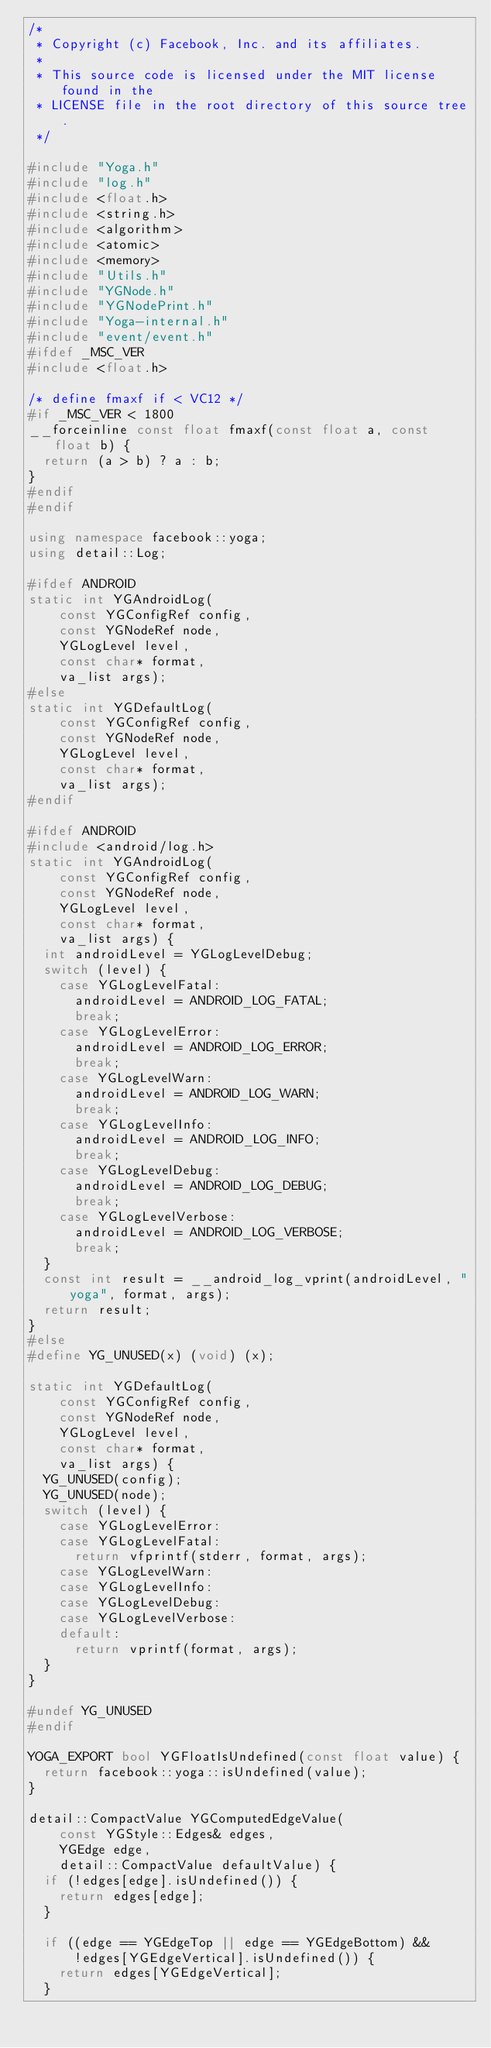<code> <loc_0><loc_0><loc_500><loc_500><_C++_>/*
 * Copyright (c) Facebook, Inc. and its affiliates.
 *
 * This source code is licensed under the MIT license found in the
 * LICENSE file in the root directory of this source tree.
 */

#include "Yoga.h"
#include "log.h"
#include <float.h>
#include <string.h>
#include <algorithm>
#include <atomic>
#include <memory>
#include "Utils.h"
#include "YGNode.h"
#include "YGNodePrint.h"
#include "Yoga-internal.h"
#include "event/event.h"
#ifdef _MSC_VER
#include <float.h>

/* define fmaxf if < VC12 */
#if _MSC_VER < 1800
__forceinline const float fmaxf(const float a, const float b) {
  return (a > b) ? a : b;
}
#endif
#endif

using namespace facebook::yoga;
using detail::Log;

#ifdef ANDROID
static int YGAndroidLog(
    const YGConfigRef config,
    const YGNodeRef node,
    YGLogLevel level,
    const char* format,
    va_list args);
#else
static int YGDefaultLog(
    const YGConfigRef config,
    const YGNodeRef node,
    YGLogLevel level,
    const char* format,
    va_list args);
#endif

#ifdef ANDROID
#include <android/log.h>
static int YGAndroidLog(
    const YGConfigRef config,
    const YGNodeRef node,
    YGLogLevel level,
    const char* format,
    va_list args) {
  int androidLevel = YGLogLevelDebug;
  switch (level) {
    case YGLogLevelFatal:
      androidLevel = ANDROID_LOG_FATAL;
      break;
    case YGLogLevelError:
      androidLevel = ANDROID_LOG_ERROR;
      break;
    case YGLogLevelWarn:
      androidLevel = ANDROID_LOG_WARN;
      break;
    case YGLogLevelInfo:
      androidLevel = ANDROID_LOG_INFO;
      break;
    case YGLogLevelDebug:
      androidLevel = ANDROID_LOG_DEBUG;
      break;
    case YGLogLevelVerbose:
      androidLevel = ANDROID_LOG_VERBOSE;
      break;
  }
  const int result = __android_log_vprint(androidLevel, "yoga", format, args);
  return result;
}
#else
#define YG_UNUSED(x) (void) (x);

static int YGDefaultLog(
    const YGConfigRef config,
    const YGNodeRef node,
    YGLogLevel level,
    const char* format,
    va_list args) {
  YG_UNUSED(config);
  YG_UNUSED(node);
  switch (level) {
    case YGLogLevelError:
    case YGLogLevelFatal:
      return vfprintf(stderr, format, args);
    case YGLogLevelWarn:
    case YGLogLevelInfo:
    case YGLogLevelDebug:
    case YGLogLevelVerbose:
    default:
      return vprintf(format, args);
  }
}

#undef YG_UNUSED
#endif

YOGA_EXPORT bool YGFloatIsUndefined(const float value) {
  return facebook::yoga::isUndefined(value);
}

detail::CompactValue YGComputedEdgeValue(
    const YGStyle::Edges& edges,
    YGEdge edge,
    detail::CompactValue defaultValue) {
  if (!edges[edge].isUndefined()) {
    return edges[edge];
  }

  if ((edge == YGEdgeTop || edge == YGEdgeBottom) &&
      !edges[YGEdgeVertical].isUndefined()) {
    return edges[YGEdgeVertical];
  }
</code> 